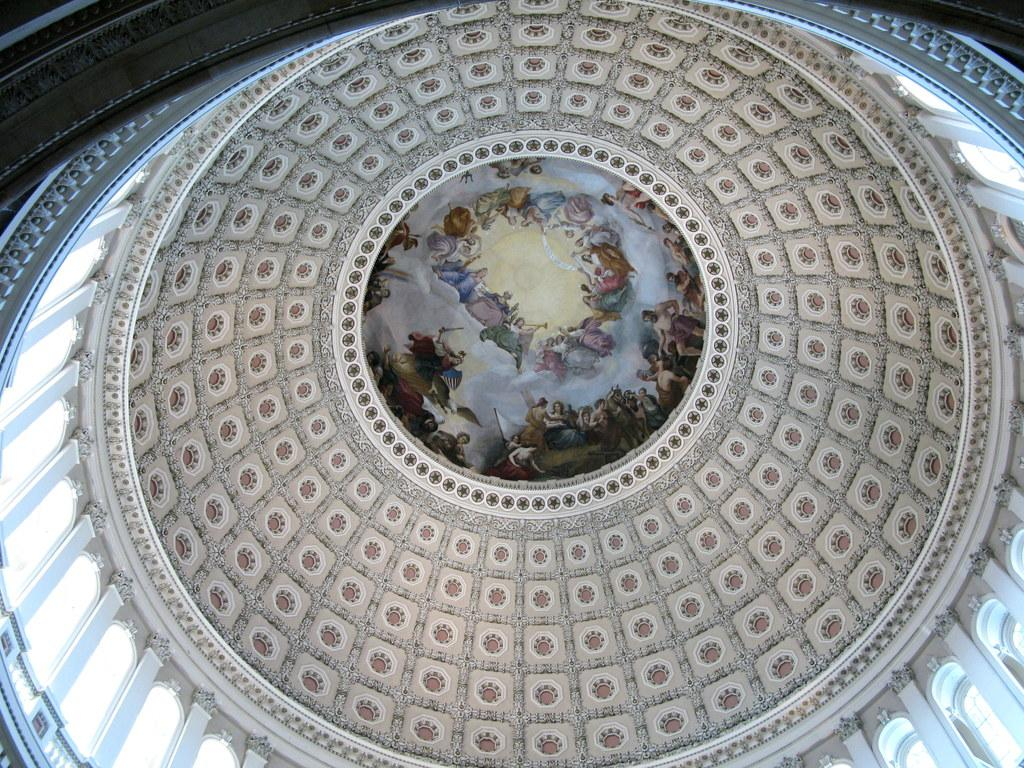What type of view is shown in the image? The image is an inside view of a building. What part of the building can be seen in the image? There is a roof visible in the image. What type of straw is being used to create motion in the image? There is no straw or motion present in the image; it is a still image of an inside view of a building with a visible roof. 